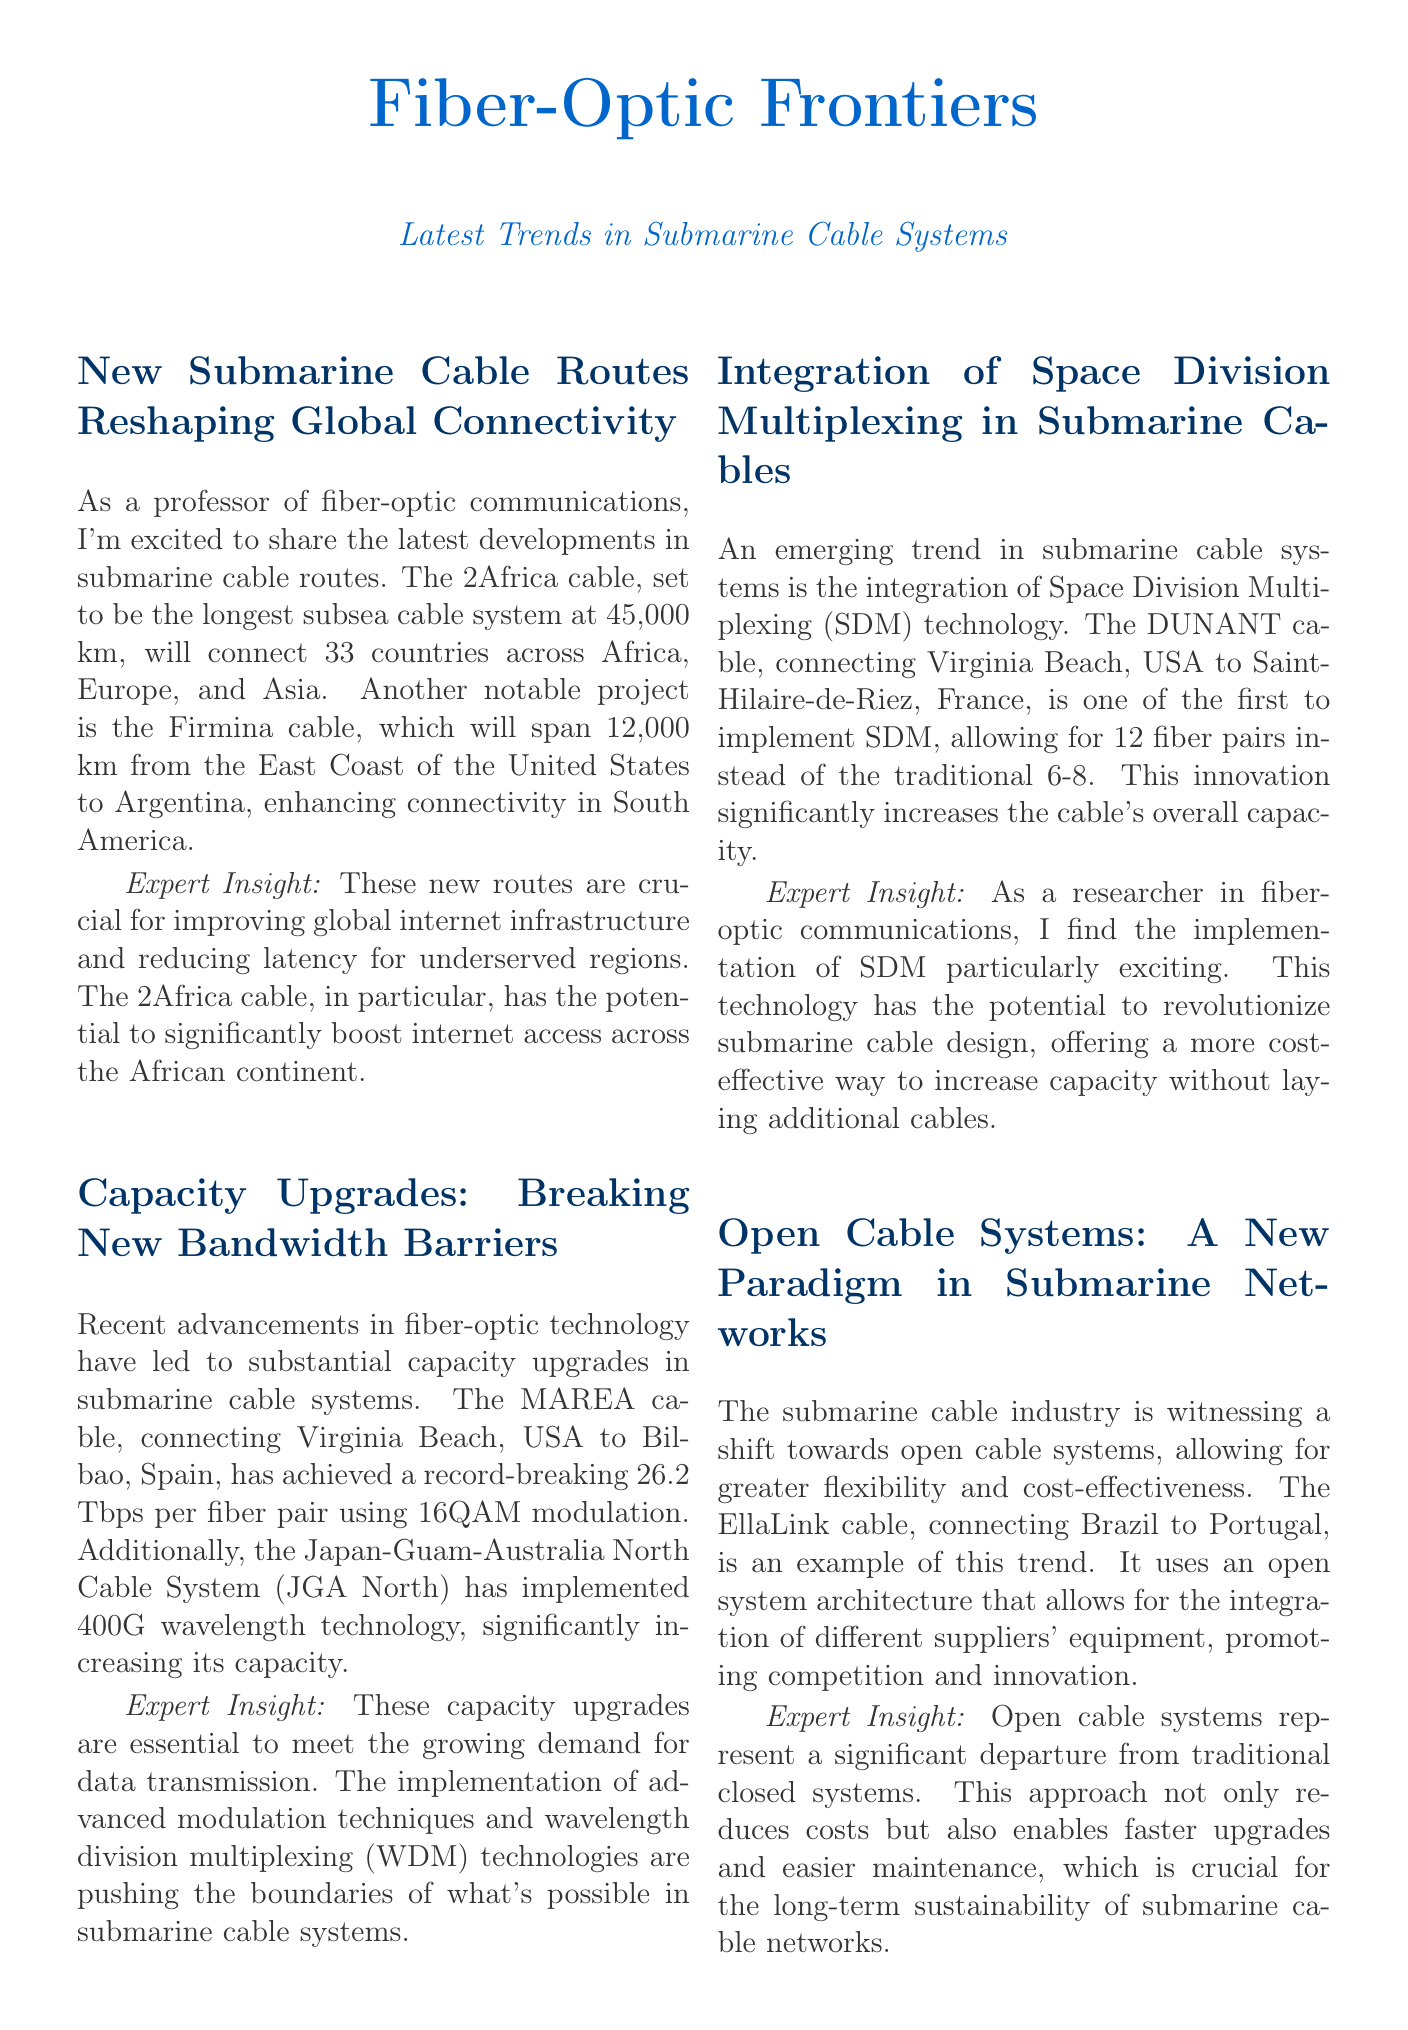What is the length of the 2Africa cable? The 2Africa cable is set to be the longest subsea cable system at 45,000 km.
Answer: 45,000 km What technology has the MAREA cable implemented? The MAREA cable has achieved a record-breaking 26.2 Tbps per fiber pair using 16QAM modulation.
Answer: 16QAM modulation What is the capacity of the JGA North after upgrades? The JGA North has implemented 400G wavelength technology, significantly increasing its capacity.
Answer: 400G wavelength technology How many fiber pairs does the DUNANT cable use? The DUNANT cable allows for 12 fiber pairs instead of the traditional 6-8.
Answer: 12 fiber pairs Which cable connects Brazil to Portugal? The EllaLink cable, connecting Brazil to Portugal, is an example of the open cable systems trend.
Answer: EllaLink What initiative aims to monitor environmental conditions using submarine cables? The SMART (Scientific Monitoring And Reliable Telecommunications) cables initiative aims to equip submarine cables with sensors.
Answer: SMART Why are open cable systems considered advantageous? Open cable systems enable faster upgrades and easier maintenance, crucial for long-term sustainability.
Answer: Faster upgrades and easier maintenance What is a significant environmental application of submarine cables mentioned? The integration of environmental monitoring capabilities for ocean dynamics and early warning systems for natural disasters.
Answer: Environmental monitoring capabilities 